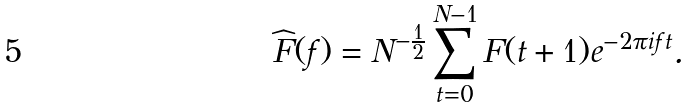Convert formula to latex. <formula><loc_0><loc_0><loc_500><loc_500>\widehat { F } ( f ) = N ^ { - \frac { 1 } { 2 } } \sum _ { t = 0 } ^ { N - 1 } F ( t + 1 ) e ^ { - 2 \pi i f t } .</formula> 